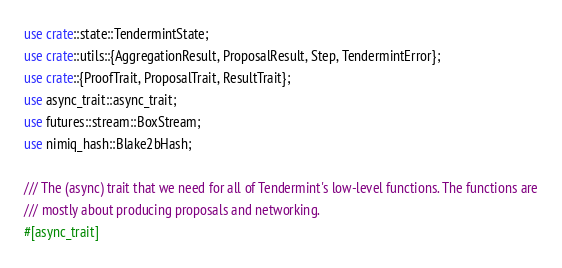<code> <loc_0><loc_0><loc_500><loc_500><_Rust_>use crate::state::TendermintState;
use crate::utils::{AggregationResult, ProposalResult, Step, TendermintError};
use crate::{ProofTrait, ProposalTrait, ResultTrait};
use async_trait::async_trait;
use futures::stream::BoxStream;
use nimiq_hash::Blake2bHash;

/// The (async) trait that we need for all of Tendermint's low-level functions. The functions are
/// mostly about producing proposals and networking.
#[async_trait]</code> 